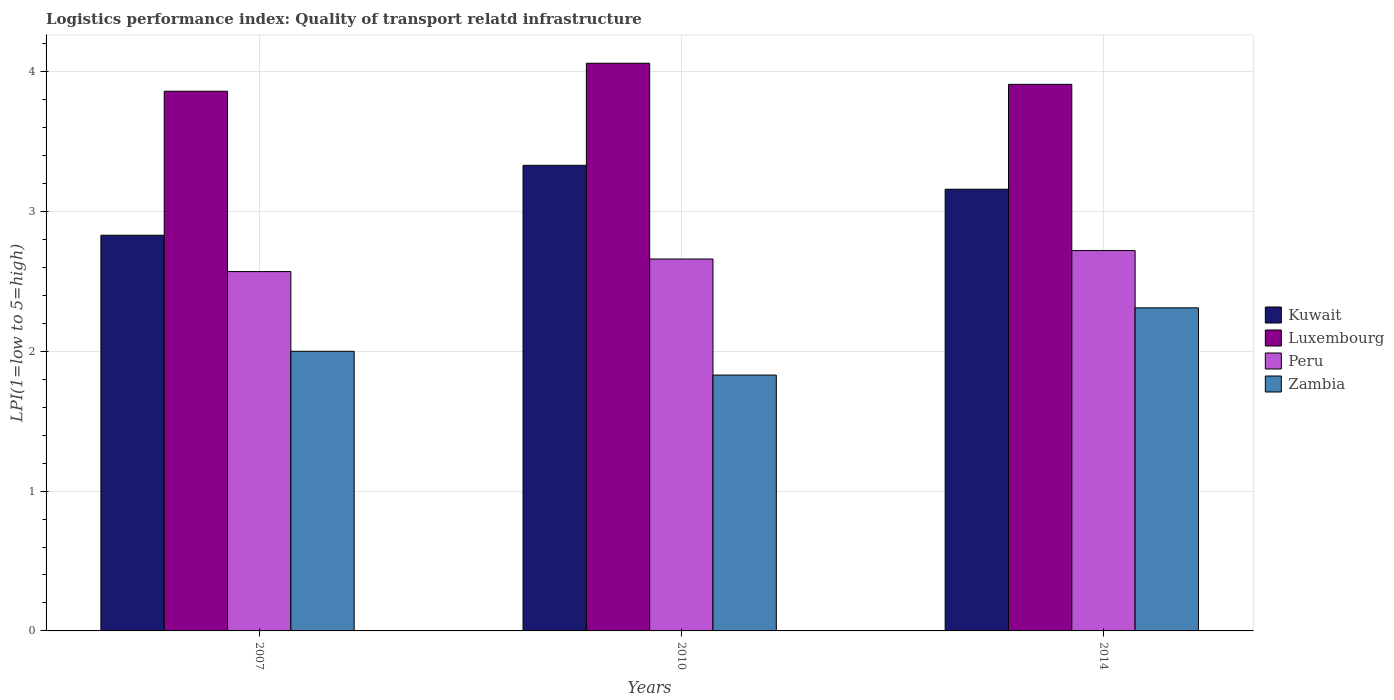How many different coloured bars are there?
Make the answer very short. 4. How many groups of bars are there?
Your answer should be very brief. 3. Are the number of bars per tick equal to the number of legend labels?
Provide a succinct answer. Yes. Are the number of bars on each tick of the X-axis equal?
Make the answer very short. Yes. How many bars are there on the 3rd tick from the left?
Offer a very short reply. 4. In how many cases, is the number of bars for a given year not equal to the number of legend labels?
Keep it short and to the point. 0. What is the logistics performance index in Luxembourg in 2014?
Provide a succinct answer. 3.91. Across all years, what is the maximum logistics performance index in Luxembourg?
Make the answer very short. 4.06. Across all years, what is the minimum logistics performance index in Luxembourg?
Keep it short and to the point. 3.86. In which year was the logistics performance index in Kuwait maximum?
Provide a short and direct response. 2010. In which year was the logistics performance index in Kuwait minimum?
Offer a very short reply. 2007. What is the total logistics performance index in Peru in the graph?
Provide a succinct answer. 7.95. What is the difference between the logistics performance index in Luxembourg in 2010 and that in 2014?
Offer a very short reply. 0.15. What is the average logistics performance index in Zambia per year?
Offer a very short reply. 2.05. In the year 2007, what is the difference between the logistics performance index in Kuwait and logistics performance index in Luxembourg?
Give a very brief answer. -1.03. What is the ratio of the logistics performance index in Luxembourg in 2010 to that in 2014?
Provide a succinct answer. 1.04. What is the difference between the highest and the second highest logistics performance index in Zambia?
Give a very brief answer. 0.31. What is the difference between the highest and the lowest logistics performance index in Peru?
Keep it short and to the point. 0.15. In how many years, is the logistics performance index in Kuwait greater than the average logistics performance index in Kuwait taken over all years?
Keep it short and to the point. 2. Is the sum of the logistics performance index in Luxembourg in 2007 and 2014 greater than the maximum logistics performance index in Peru across all years?
Offer a terse response. Yes. Is it the case that in every year, the sum of the logistics performance index in Luxembourg and logistics performance index in Peru is greater than the sum of logistics performance index in Zambia and logistics performance index in Kuwait?
Your answer should be compact. No. What does the 1st bar from the right in 2007 represents?
Make the answer very short. Zambia. How many bars are there?
Provide a short and direct response. 12. Are all the bars in the graph horizontal?
Provide a succinct answer. No. How many years are there in the graph?
Your response must be concise. 3. Does the graph contain any zero values?
Provide a succinct answer. No. Where does the legend appear in the graph?
Provide a succinct answer. Center right. How many legend labels are there?
Offer a very short reply. 4. How are the legend labels stacked?
Your answer should be compact. Vertical. What is the title of the graph?
Make the answer very short. Logistics performance index: Quality of transport relatd infrastructure. What is the label or title of the X-axis?
Offer a terse response. Years. What is the label or title of the Y-axis?
Ensure brevity in your answer.  LPI(1=low to 5=high). What is the LPI(1=low to 5=high) in Kuwait in 2007?
Offer a terse response. 2.83. What is the LPI(1=low to 5=high) of Luxembourg in 2007?
Your answer should be compact. 3.86. What is the LPI(1=low to 5=high) in Peru in 2007?
Your answer should be compact. 2.57. What is the LPI(1=low to 5=high) in Zambia in 2007?
Your answer should be very brief. 2. What is the LPI(1=low to 5=high) of Kuwait in 2010?
Your response must be concise. 3.33. What is the LPI(1=low to 5=high) of Luxembourg in 2010?
Give a very brief answer. 4.06. What is the LPI(1=low to 5=high) in Peru in 2010?
Provide a succinct answer. 2.66. What is the LPI(1=low to 5=high) in Zambia in 2010?
Ensure brevity in your answer.  1.83. What is the LPI(1=low to 5=high) in Kuwait in 2014?
Make the answer very short. 3.16. What is the LPI(1=low to 5=high) in Luxembourg in 2014?
Offer a very short reply. 3.91. What is the LPI(1=low to 5=high) of Peru in 2014?
Offer a very short reply. 2.72. What is the LPI(1=low to 5=high) of Zambia in 2014?
Your answer should be very brief. 2.31. Across all years, what is the maximum LPI(1=low to 5=high) in Kuwait?
Provide a succinct answer. 3.33. Across all years, what is the maximum LPI(1=low to 5=high) in Luxembourg?
Provide a succinct answer. 4.06. Across all years, what is the maximum LPI(1=low to 5=high) of Peru?
Provide a short and direct response. 2.72. Across all years, what is the maximum LPI(1=low to 5=high) of Zambia?
Your answer should be compact. 2.31. Across all years, what is the minimum LPI(1=low to 5=high) of Kuwait?
Provide a short and direct response. 2.83. Across all years, what is the minimum LPI(1=low to 5=high) of Luxembourg?
Offer a very short reply. 3.86. Across all years, what is the minimum LPI(1=low to 5=high) of Peru?
Give a very brief answer. 2.57. Across all years, what is the minimum LPI(1=low to 5=high) of Zambia?
Your answer should be very brief. 1.83. What is the total LPI(1=low to 5=high) of Kuwait in the graph?
Offer a terse response. 9.32. What is the total LPI(1=low to 5=high) of Luxembourg in the graph?
Provide a short and direct response. 11.83. What is the total LPI(1=low to 5=high) of Peru in the graph?
Provide a short and direct response. 7.95. What is the total LPI(1=low to 5=high) of Zambia in the graph?
Keep it short and to the point. 6.14. What is the difference between the LPI(1=low to 5=high) in Kuwait in 2007 and that in 2010?
Your answer should be very brief. -0.5. What is the difference between the LPI(1=low to 5=high) of Peru in 2007 and that in 2010?
Provide a succinct answer. -0.09. What is the difference between the LPI(1=low to 5=high) of Zambia in 2007 and that in 2010?
Ensure brevity in your answer.  0.17. What is the difference between the LPI(1=low to 5=high) of Kuwait in 2007 and that in 2014?
Your answer should be very brief. -0.33. What is the difference between the LPI(1=low to 5=high) in Luxembourg in 2007 and that in 2014?
Provide a succinct answer. -0.05. What is the difference between the LPI(1=low to 5=high) in Peru in 2007 and that in 2014?
Provide a succinct answer. -0.15. What is the difference between the LPI(1=low to 5=high) in Zambia in 2007 and that in 2014?
Your answer should be very brief. -0.31. What is the difference between the LPI(1=low to 5=high) in Kuwait in 2010 and that in 2014?
Provide a succinct answer. 0.17. What is the difference between the LPI(1=low to 5=high) in Luxembourg in 2010 and that in 2014?
Give a very brief answer. 0.15. What is the difference between the LPI(1=low to 5=high) of Peru in 2010 and that in 2014?
Your answer should be compact. -0.06. What is the difference between the LPI(1=low to 5=high) in Zambia in 2010 and that in 2014?
Ensure brevity in your answer.  -0.48. What is the difference between the LPI(1=low to 5=high) in Kuwait in 2007 and the LPI(1=low to 5=high) in Luxembourg in 2010?
Give a very brief answer. -1.23. What is the difference between the LPI(1=low to 5=high) of Kuwait in 2007 and the LPI(1=low to 5=high) of Peru in 2010?
Give a very brief answer. 0.17. What is the difference between the LPI(1=low to 5=high) in Kuwait in 2007 and the LPI(1=low to 5=high) in Zambia in 2010?
Ensure brevity in your answer.  1. What is the difference between the LPI(1=low to 5=high) of Luxembourg in 2007 and the LPI(1=low to 5=high) of Zambia in 2010?
Your answer should be compact. 2.03. What is the difference between the LPI(1=low to 5=high) in Peru in 2007 and the LPI(1=low to 5=high) in Zambia in 2010?
Make the answer very short. 0.74. What is the difference between the LPI(1=low to 5=high) of Kuwait in 2007 and the LPI(1=low to 5=high) of Luxembourg in 2014?
Your response must be concise. -1.08. What is the difference between the LPI(1=low to 5=high) of Kuwait in 2007 and the LPI(1=low to 5=high) of Peru in 2014?
Offer a terse response. 0.11. What is the difference between the LPI(1=low to 5=high) of Kuwait in 2007 and the LPI(1=low to 5=high) of Zambia in 2014?
Make the answer very short. 0.52. What is the difference between the LPI(1=low to 5=high) of Luxembourg in 2007 and the LPI(1=low to 5=high) of Peru in 2014?
Offer a very short reply. 1.14. What is the difference between the LPI(1=low to 5=high) in Luxembourg in 2007 and the LPI(1=low to 5=high) in Zambia in 2014?
Offer a very short reply. 1.55. What is the difference between the LPI(1=low to 5=high) in Peru in 2007 and the LPI(1=low to 5=high) in Zambia in 2014?
Ensure brevity in your answer.  0.26. What is the difference between the LPI(1=low to 5=high) in Kuwait in 2010 and the LPI(1=low to 5=high) in Luxembourg in 2014?
Make the answer very short. -0.58. What is the difference between the LPI(1=low to 5=high) in Kuwait in 2010 and the LPI(1=low to 5=high) in Peru in 2014?
Provide a short and direct response. 0.61. What is the difference between the LPI(1=low to 5=high) of Kuwait in 2010 and the LPI(1=low to 5=high) of Zambia in 2014?
Keep it short and to the point. 1.02. What is the difference between the LPI(1=low to 5=high) in Luxembourg in 2010 and the LPI(1=low to 5=high) in Peru in 2014?
Your answer should be very brief. 1.34. What is the difference between the LPI(1=low to 5=high) of Luxembourg in 2010 and the LPI(1=low to 5=high) of Zambia in 2014?
Give a very brief answer. 1.75. What is the difference between the LPI(1=low to 5=high) in Peru in 2010 and the LPI(1=low to 5=high) in Zambia in 2014?
Offer a terse response. 0.35. What is the average LPI(1=low to 5=high) of Kuwait per year?
Offer a terse response. 3.11. What is the average LPI(1=low to 5=high) of Luxembourg per year?
Make the answer very short. 3.94. What is the average LPI(1=low to 5=high) of Peru per year?
Offer a very short reply. 2.65. What is the average LPI(1=low to 5=high) of Zambia per year?
Give a very brief answer. 2.05. In the year 2007, what is the difference between the LPI(1=low to 5=high) of Kuwait and LPI(1=low to 5=high) of Luxembourg?
Your answer should be very brief. -1.03. In the year 2007, what is the difference between the LPI(1=low to 5=high) of Kuwait and LPI(1=low to 5=high) of Peru?
Your answer should be compact. 0.26. In the year 2007, what is the difference between the LPI(1=low to 5=high) of Kuwait and LPI(1=low to 5=high) of Zambia?
Keep it short and to the point. 0.83. In the year 2007, what is the difference between the LPI(1=low to 5=high) in Luxembourg and LPI(1=low to 5=high) in Peru?
Give a very brief answer. 1.29. In the year 2007, what is the difference between the LPI(1=low to 5=high) of Luxembourg and LPI(1=low to 5=high) of Zambia?
Give a very brief answer. 1.86. In the year 2007, what is the difference between the LPI(1=low to 5=high) in Peru and LPI(1=low to 5=high) in Zambia?
Give a very brief answer. 0.57. In the year 2010, what is the difference between the LPI(1=low to 5=high) in Kuwait and LPI(1=low to 5=high) in Luxembourg?
Give a very brief answer. -0.73. In the year 2010, what is the difference between the LPI(1=low to 5=high) of Kuwait and LPI(1=low to 5=high) of Peru?
Your answer should be compact. 0.67. In the year 2010, what is the difference between the LPI(1=low to 5=high) in Kuwait and LPI(1=low to 5=high) in Zambia?
Provide a short and direct response. 1.5. In the year 2010, what is the difference between the LPI(1=low to 5=high) of Luxembourg and LPI(1=low to 5=high) of Zambia?
Your response must be concise. 2.23. In the year 2010, what is the difference between the LPI(1=low to 5=high) in Peru and LPI(1=low to 5=high) in Zambia?
Ensure brevity in your answer.  0.83. In the year 2014, what is the difference between the LPI(1=low to 5=high) of Kuwait and LPI(1=low to 5=high) of Luxembourg?
Your response must be concise. -0.75. In the year 2014, what is the difference between the LPI(1=low to 5=high) in Kuwait and LPI(1=low to 5=high) in Peru?
Give a very brief answer. 0.44. In the year 2014, what is the difference between the LPI(1=low to 5=high) of Kuwait and LPI(1=low to 5=high) of Zambia?
Your answer should be very brief. 0.85. In the year 2014, what is the difference between the LPI(1=low to 5=high) in Luxembourg and LPI(1=low to 5=high) in Peru?
Provide a succinct answer. 1.19. In the year 2014, what is the difference between the LPI(1=low to 5=high) of Luxembourg and LPI(1=low to 5=high) of Zambia?
Your answer should be compact. 1.6. In the year 2014, what is the difference between the LPI(1=low to 5=high) in Peru and LPI(1=low to 5=high) in Zambia?
Offer a very short reply. 0.41. What is the ratio of the LPI(1=low to 5=high) in Kuwait in 2007 to that in 2010?
Your answer should be very brief. 0.85. What is the ratio of the LPI(1=low to 5=high) in Luxembourg in 2007 to that in 2010?
Give a very brief answer. 0.95. What is the ratio of the LPI(1=low to 5=high) of Peru in 2007 to that in 2010?
Your answer should be very brief. 0.97. What is the ratio of the LPI(1=low to 5=high) of Zambia in 2007 to that in 2010?
Keep it short and to the point. 1.09. What is the ratio of the LPI(1=low to 5=high) of Kuwait in 2007 to that in 2014?
Your answer should be very brief. 0.9. What is the ratio of the LPI(1=low to 5=high) in Luxembourg in 2007 to that in 2014?
Provide a succinct answer. 0.99. What is the ratio of the LPI(1=low to 5=high) of Peru in 2007 to that in 2014?
Provide a short and direct response. 0.94. What is the ratio of the LPI(1=low to 5=high) of Zambia in 2007 to that in 2014?
Your response must be concise. 0.87. What is the ratio of the LPI(1=low to 5=high) of Kuwait in 2010 to that in 2014?
Your answer should be compact. 1.05. What is the ratio of the LPI(1=low to 5=high) of Luxembourg in 2010 to that in 2014?
Your answer should be compact. 1.04. What is the ratio of the LPI(1=low to 5=high) of Peru in 2010 to that in 2014?
Ensure brevity in your answer.  0.98. What is the ratio of the LPI(1=low to 5=high) of Zambia in 2010 to that in 2014?
Offer a terse response. 0.79. What is the difference between the highest and the second highest LPI(1=low to 5=high) in Kuwait?
Offer a very short reply. 0.17. What is the difference between the highest and the second highest LPI(1=low to 5=high) of Luxembourg?
Make the answer very short. 0.15. What is the difference between the highest and the second highest LPI(1=low to 5=high) of Peru?
Provide a succinct answer. 0.06. What is the difference between the highest and the second highest LPI(1=low to 5=high) of Zambia?
Your response must be concise. 0.31. What is the difference between the highest and the lowest LPI(1=low to 5=high) in Kuwait?
Your answer should be compact. 0.5. What is the difference between the highest and the lowest LPI(1=low to 5=high) in Peru?
Give a very brief answer. 0.15. What is the difference between the highest and the lowest LPI(1=low to 5=high) of Zambia?
Give a very brief answer. 0.48. 